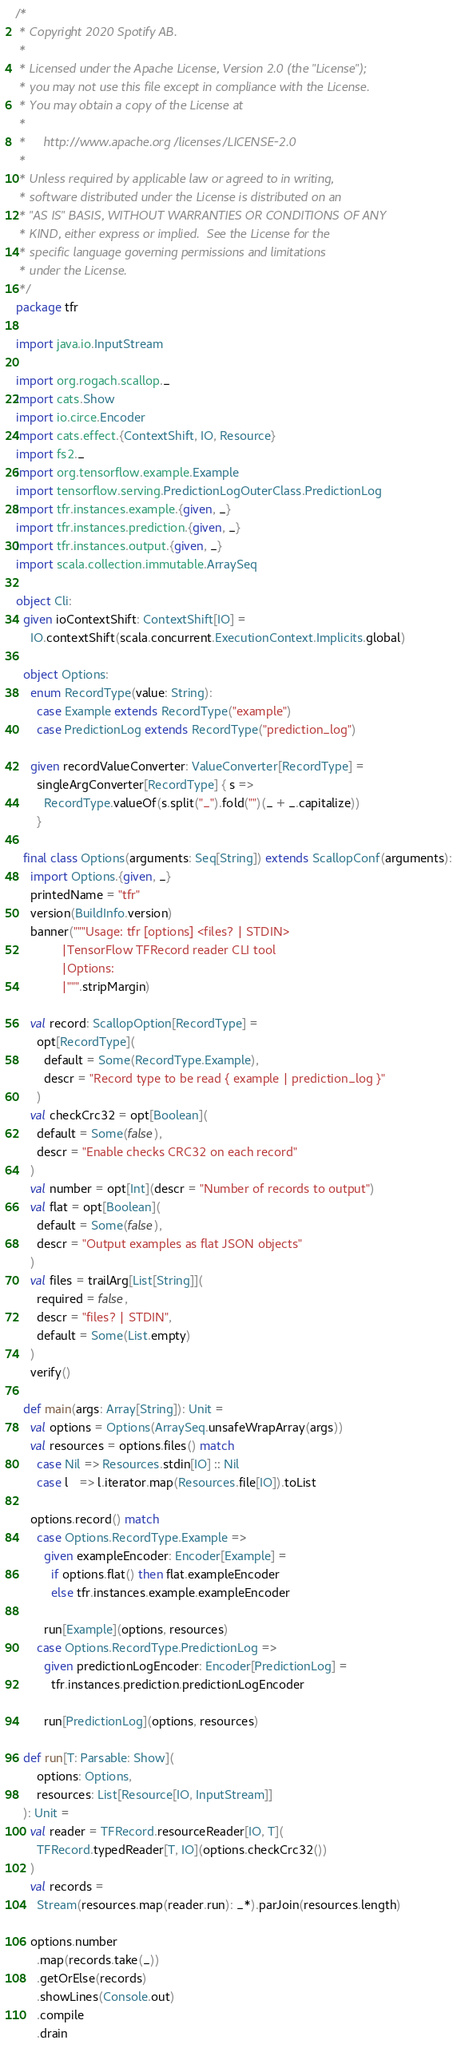Convert code to text. <code><loc_0><loc_0><loc_500><loc_500><_Scala_>/*
 * Copyright 2020 Spotify AB.
 *
 * Licensed under the Apache License, Version 2.0 (the "License");
 * you may not use this file except in compliance with the License.
 * You may obtain a copy of the License at
 *
 *     http://www.apache.org/licenses/LICENSE-2.0
 *
 * Unless required by applicable law or agreed to in writing,
 * software distributed under the License is distributed on an
 * "AS IS" BASIS, WITHOUT WARRANTIES OR CONDITIONS OF ANY
 * KIND, either express or implied.  See the License for the
 * specific language governing permissions and limitations
 * under the License.
 */
package tfr

import java.io.InputStream

import org.rogach.scallop._
import cats.Show
import io.circe.Encoder
import cats.effect.{ContextShift, IO, Resource}
import fs2._
import org.tensorflow.example.Example
import tensorflow.serving.PredictionLogOuterClass.PredictionLog
import tfr.instances.example.{given, _}
import tfr.instances.prediction.{given, _}
import tfr.instances.output.{given, _}
import scala.collection.immutable.ArraySeq

object Cli:
  given ioContextShift: ContextShift[IO] =
    IO.contextShift(scala.concurrent.ExecutionContext.Implicits.global)

  object Options:
    enum RecordType(value: String):
      case Example extends RecordType("example")
      case PredictionLog extends RecordType("prediction_log")

    given recordValueConverter: ValueConverter[RecordType] =
      singleArgConverter[RecordType] { s =>
        RecordType.valueOf(s.split("_").fold("")(_ + _.capitalize))
      }

  final class Options(arguments: Seq[String]) extends ScallopConf(arguments):
    import Options.{given, _}
    printedName = "tfr"
    version(BuildInfo.version)
    banner("""Usage: tfr [options] <files? | STDIN>
             |TensorFlow TFRecord reader CLI tool
             |Options:
             |""".stripMargin)

    val record: ScallopOption[RecordType] =
      opt[RecordType](
        default = Some(RecordType.Example),
        descr = "Record type to be read { example | prediction_log }"
      )
    val checkCrc32 = opt[Boolean](
      default = Some(false),
      descr = "Enable checks CRC32 on each record"
    )
    val number = opt[Int](descr = "Number of records to output")
    val flat = opt[Boolean](
      default = Some(false),
      descr = "Output examples as flat JSON objects"
    )
    val files = trailArg[List[String]](
      required = false,
      descr = "files? | STDIN",
      default = Some(List.empty)
    )
    verify()

  def main(args: Array[String]): Unit =
    val options = Options(ArraySeq.unsafeWrapArray(args))
    val resources = options.files() match
      case Nil => Resources.stdin[IO] :: Nil
      case l   => l.iterator.map(Resources.file[IO]).toList

    options.record() match
      case Options.RecordType.Example =>
        given exampleEncoder: Encoder[Example] =
          if options.flat() then flat.exampleEncoder
          else tfr.instances.example.exampleEncoder

        run[Example](options, resources)
      case Options.RecordType.PredictionLog =>
        given predictionLogEncoder: Encoder[PredictionLog] =
          tfr.instances.prediction.predictionLogEncoder

        run[PredictionLog](options, resources)

  def run[T: Parsable: Show](
      options: Options,
      resources: List[Resource[IO, InputStream]]
  ): Unit =
    val reader = TFRecord.resourceReader[IO, T](
      TFRecord.typedReader[T, IO](options.checkCrc32())
    )
    val records =
      Stream(resources.map(reader.run): _*).parJoin(resources.length)

    options.number
      .map(records.take(_))
      .getOrElse(records)
      .showLines(Console.out)
      .compile
      .drain</code> 